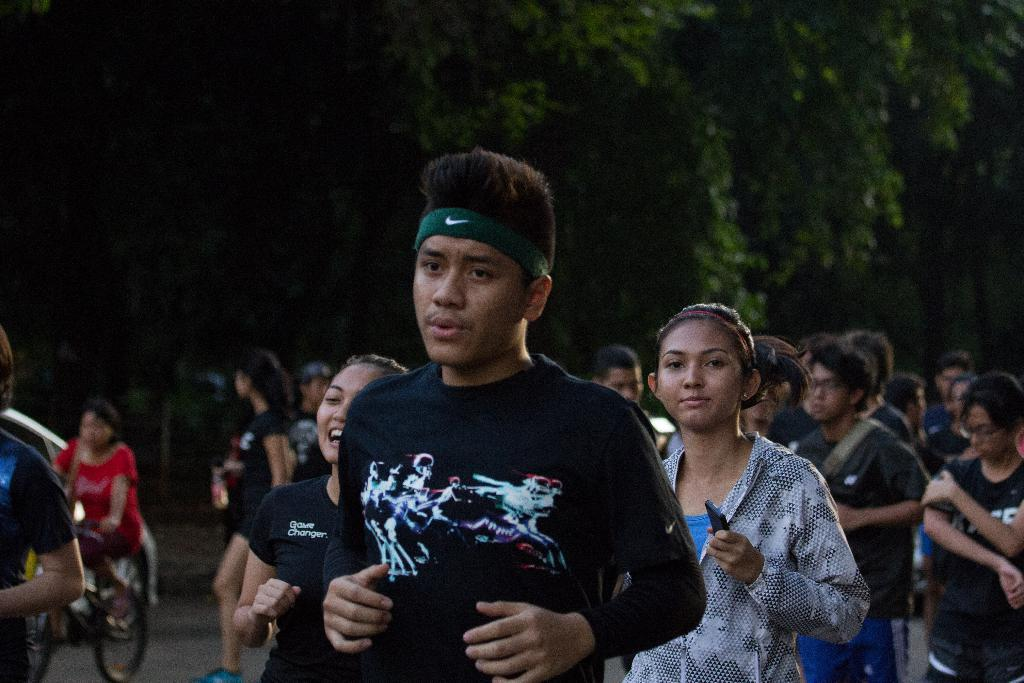What is the main subject of the image? The main subject of the image is a group of people. What else can be seen in the image besides the group of people? There are vehicles on the road and trees in the background of the image. What type of plastic suit is the person in the image wearing? There is no person wearing a plastic suit in the image. 